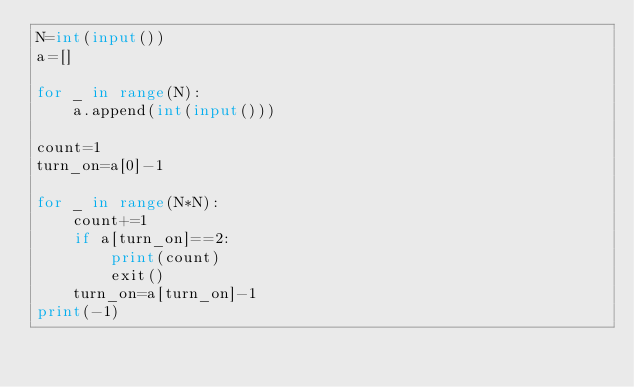Convert code to text. <code><loc_0><loc_0><loc_500><loc_500><_Python_>N=int(input())
a=[]

for _ in range(N):
    a.append(int(input()))

count=1
turn_on=a[0]-1

for _ in range(N*N):
    count+=1
    if a[turn_on]==2:
        print(count)
        exit()
    turn_on=a[turn_on]-1
print(-1)</code> 